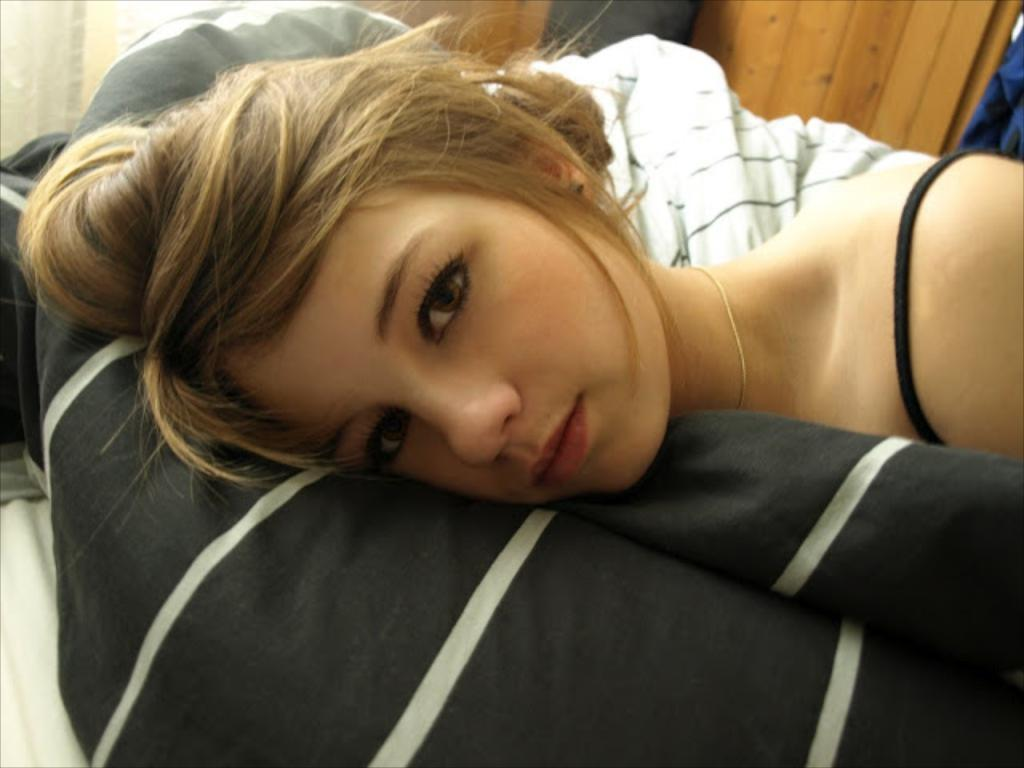What is the person in the image doing? The person is laying on a black color cloth. What can be seen in the background of the image? There are cloths and a wooden wall in the background of the image. What type of oil can be seen dripping from the icicle in the image? There is no oil or icicle present in the image. 